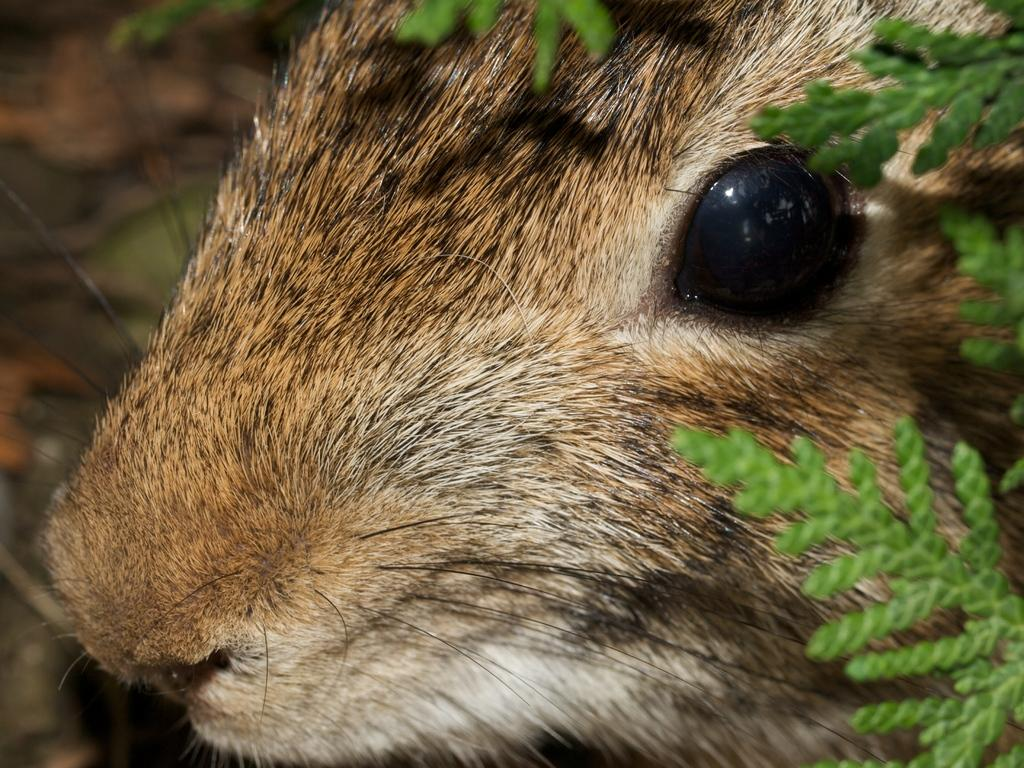What is the main subject of the image? There is a closer view of an animal in the image. What else can be seen in the image besides the animal? There are plants visible in the image. How is the background of the image depicted? The background of the image is blurred. What type of cake is being served to the cub in the image? There is no cake or cub present in the image; it features a closer view of an animal and plants. 